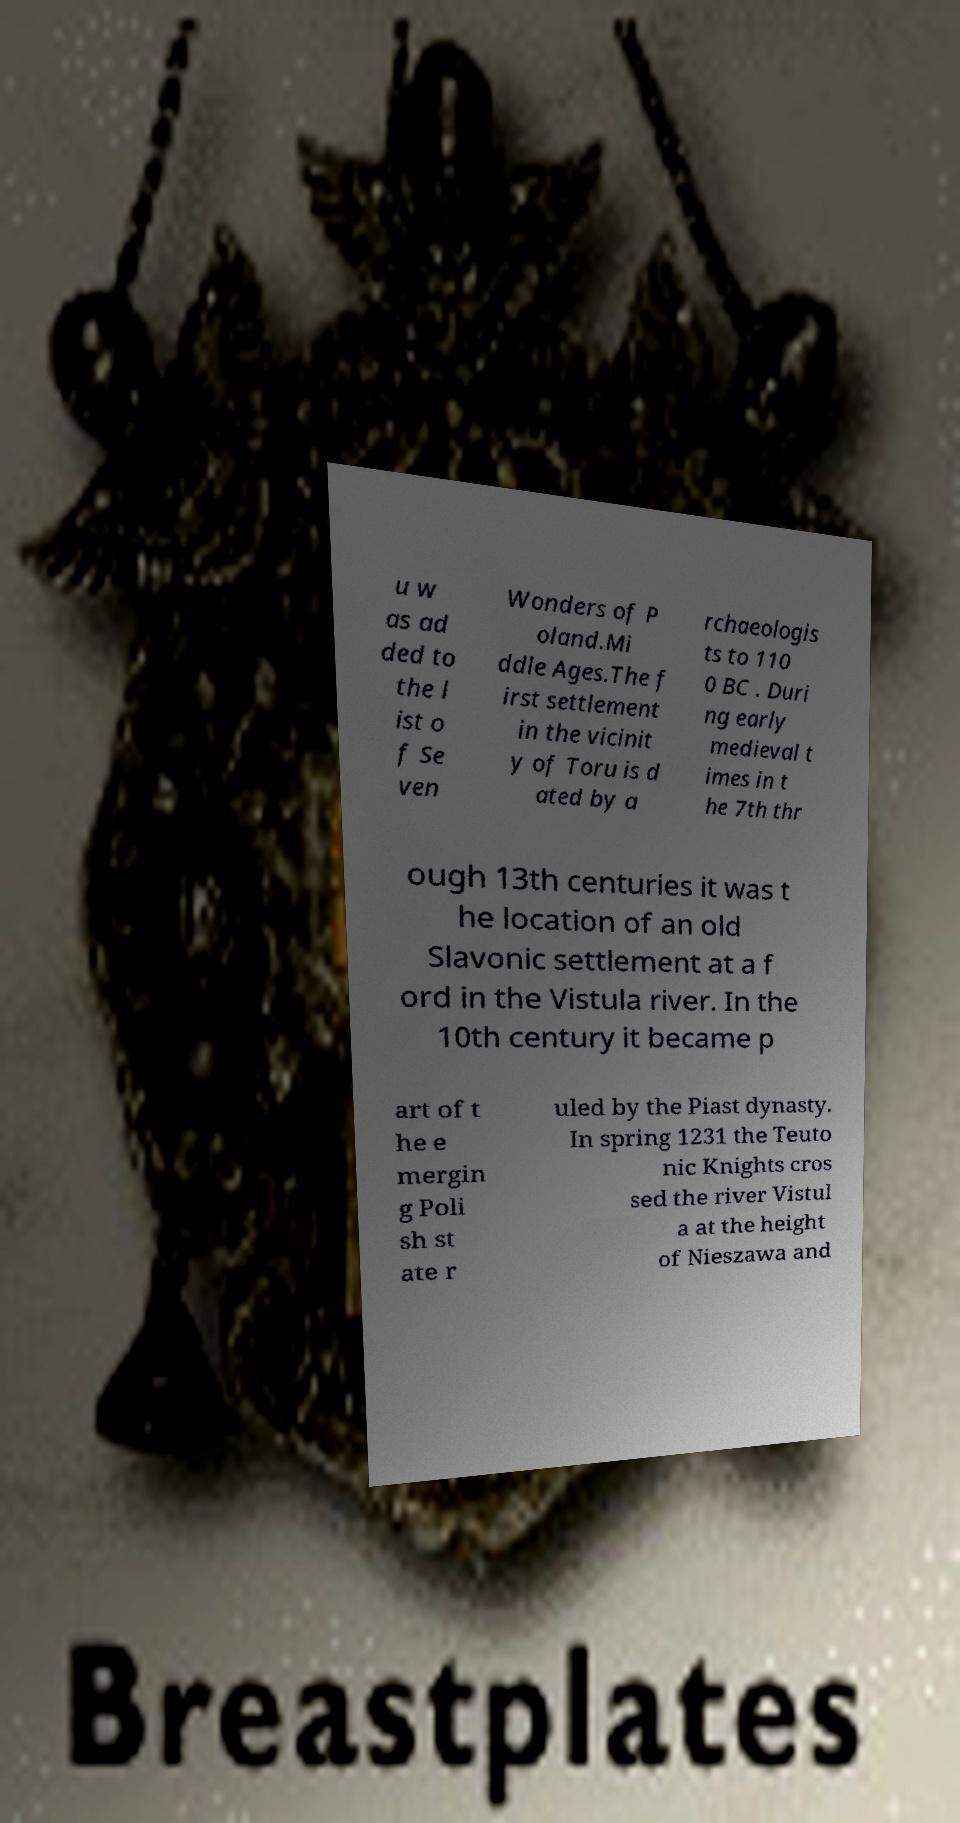I need the written content from this picture converted into text. Can you do that? u w as ad ded to the l ist o f Se ven Wonders of P oland.Mi ddle Ages.The f irst settlement in the vicinit y of Toru is d ated by a rchaeologis ts to 110 0 BC . Duri ng early medieval t imes in t he 7th thr ough 13th centuries it was t he location of an old Slavonic settlement at a f ord in the Vistula river. In the 10th century it became p art of t he e mergin g Poli sh st ate r uled by the Piast dynasty. In spring 1231 the Teuto nic Knights cros sed the river Vistul a at the height of Nieszawa and 